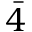<formula> <loc_0><loc_0><loc_500><loc_500>\bar { 4 }</formula> 